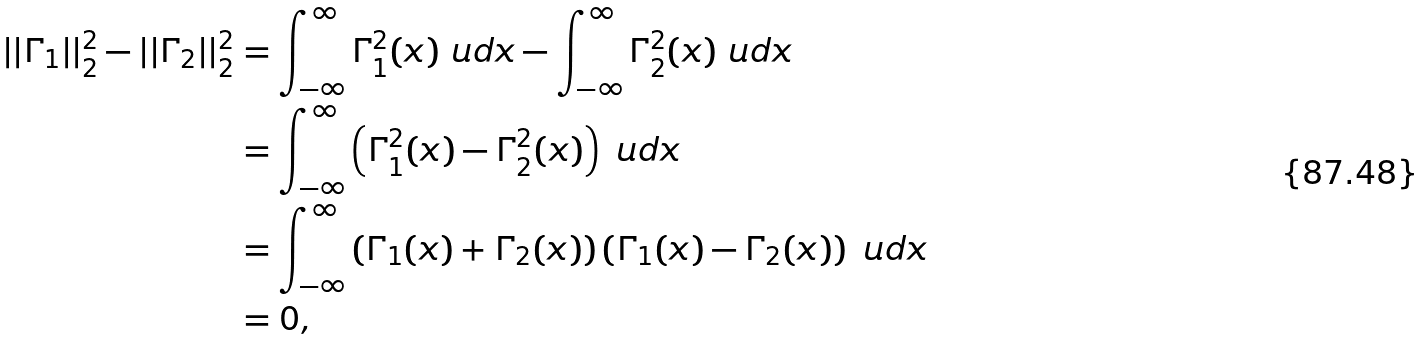Convert formula to latex. <formula><loc_0><loc_0><loc_500><loc_500>| | \Gamma _ { 1 } | | _ { 2 } ^ { 2 } - | | \Gamma _ { 2 } | | _ { 2 } ^ { 2 } & = \int _ { - \infty } ^ { \infty } \Gamma _ { 1 } ^ { 2 } ( x ) \ u d x - \int _ { - \infty } ^ { \infty } \Gamma _ { 2 } ^ { 2 } ( x ) \ u d x \\ & = \int _ { - \infty } ^ { \infty } \left ( \Gamma _ { 1 } ^ { 2 } ( x ) - \Gamma _ { 2 } ^ { 2 } ( x ) \right ) \ u d x \\ & = \int _ { - \infty } ^ { \infty } \left ( \Gamma _ { 1 } ( x ) + \Gamma _ { 2 } ( x ) \right ) \left ( \Gamma _ { 1 } ( x ) - \Gamma _ { 2 } ( x ) \right ) \ u d x \\ & = 0 ,</formula> 